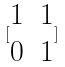<formula> <loc_0><loc_0><loc_500><loc_500>[ \begin{matrix} 1 & 1 \\ 0 & 1 \end{matrix} ]</formula> 